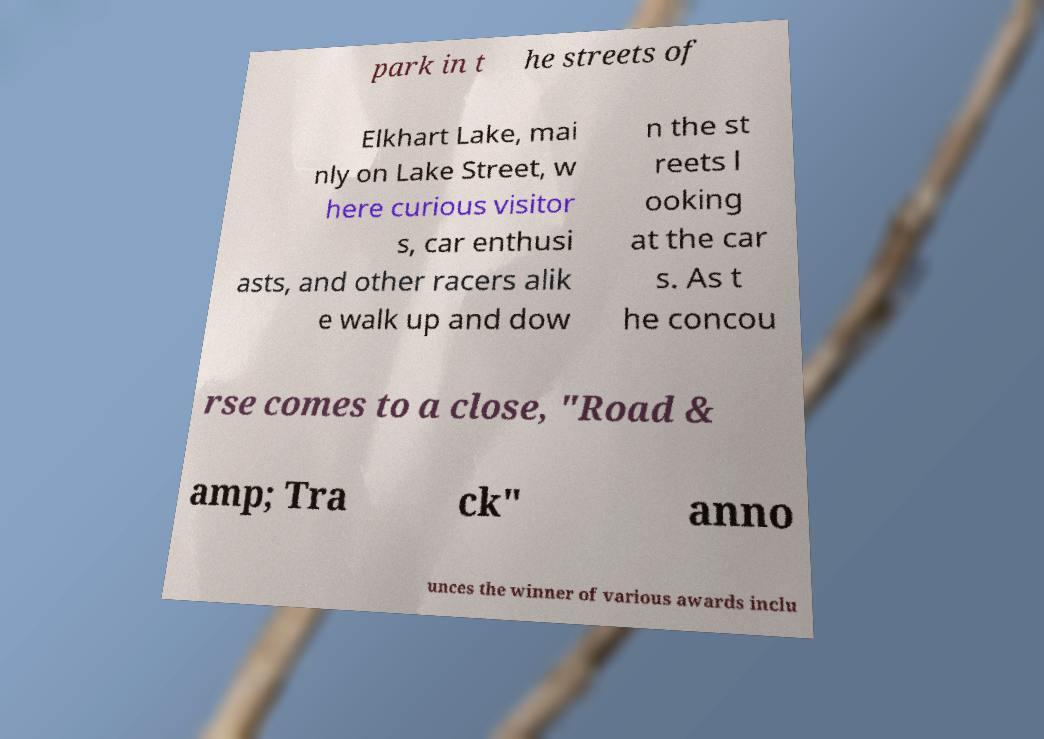Could you extract and type out the text from this image? park in t he streets of Elkhart Lake, mai nly on Lake Street, w here curious visitor s, car enthusi asts, and other racers alik e walk up and dow n the st reets l ooking at the car s. As t he concou rse comes to a close, "Road & amp; Tra ck" anno unces the winner of various awards inclu 